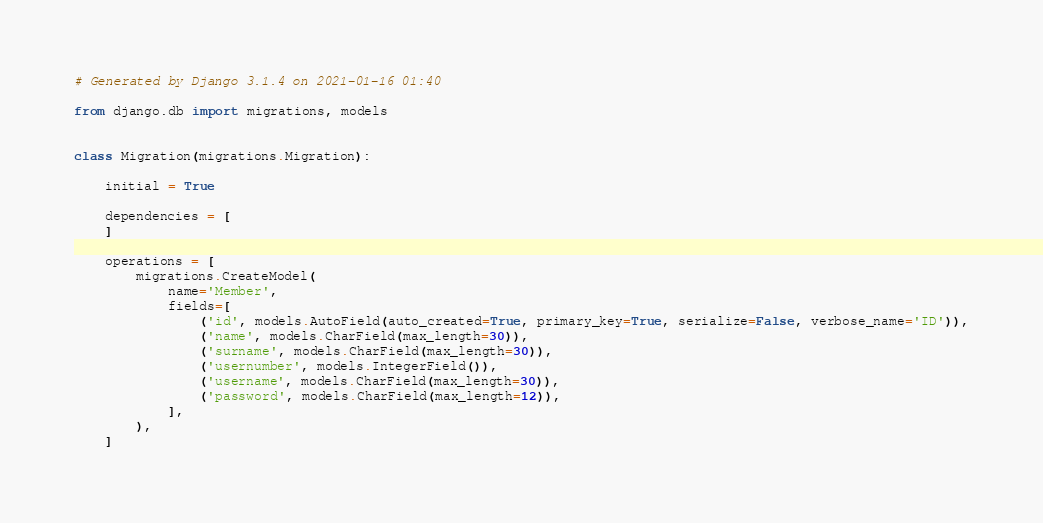Convert code to text. <code><loc_0><loc_0><loc_500><loc_500><_Python_># Generated by Django 3.1.4 on 2021-01-16 01:40

from django.db import migrations, models


class Migration(migrations.Migration):

    initial = True

    dependencies = [
    ]

    operations = [
        migrations.CreateModel(
            name='Member',
            fields=[
                ('id', models.AutoField(auto_created=True, primary_key=True, serialize=False, verbose_name='ID')),
                ('name', models.CharField(max_length=30)),
                ('surname', models.CharField(max_length=30)),
                ('usernumber', models.IntegerField()),
                ('username', models.CharField(max_length=30)),
                ('password', models.CharField(max_length=12)),
            ],
        ),
    ]
</code> 